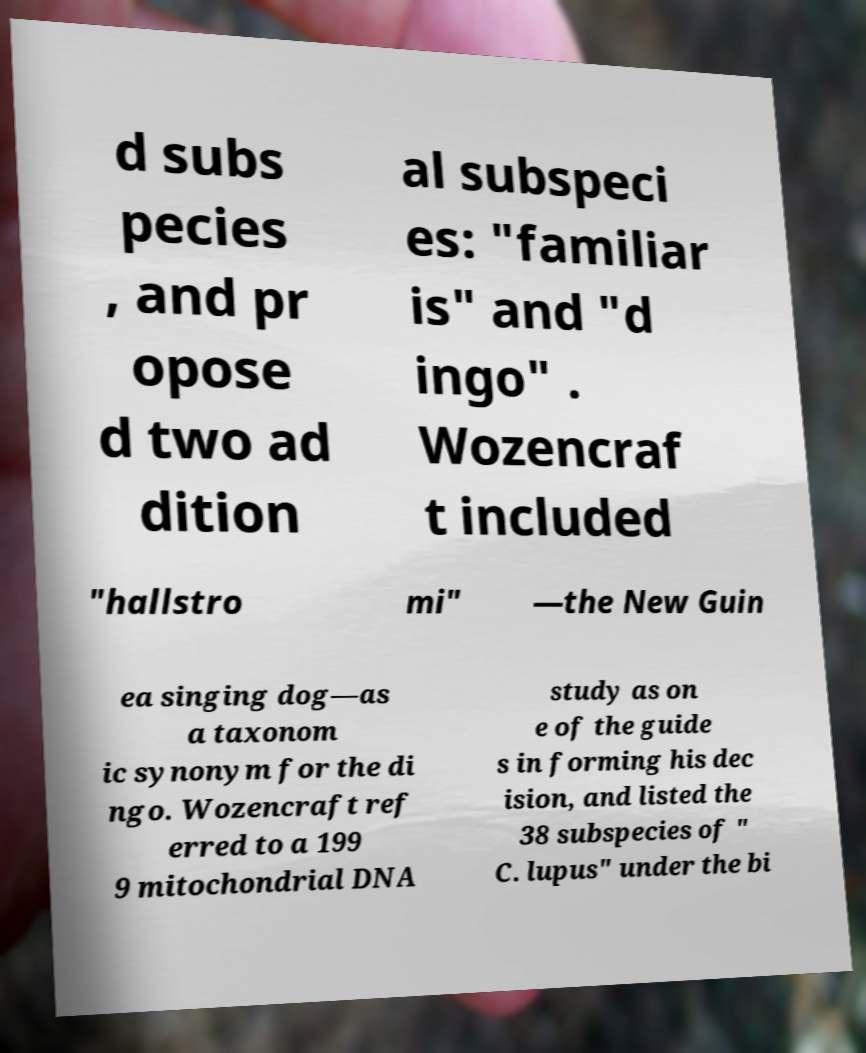Please identify and transcribe the text found in this image. d subs pecies , and pr opose d two ad dition al subspeci es: "familiar is" and "d ingo" . Wozencraf t included "hallstro mi" —the New Guin ea singing dog—as a taxonom ic synonym for the di ngo. Wozencraft ref erred to a 199 9 mitochondrial DNA study as on e of the guide s in forming his dec ision, and listed the 38 subspecies of " C. lupus" under the bi 